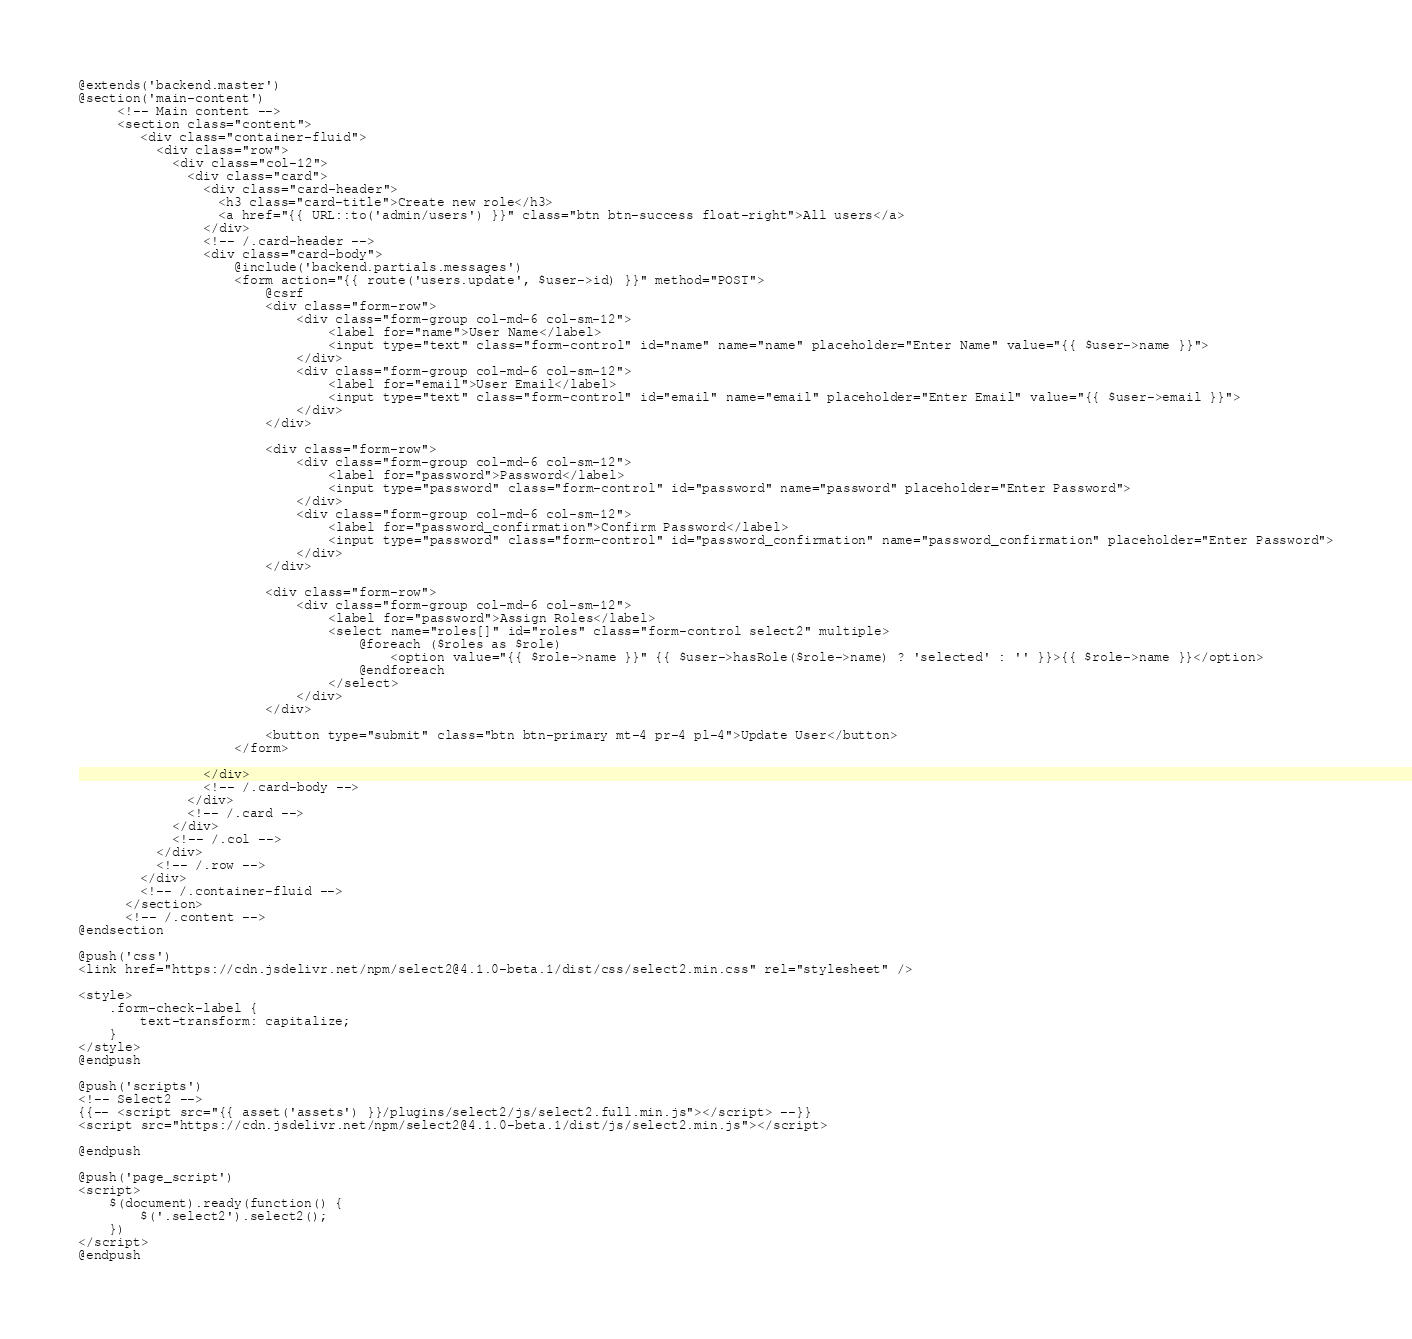<code> <loc_0><loc_0><loc_500><loc_500><_PHP_>@extends('backend.master')
@section('main-content')
     <!-- Main content -->
     <section class="content">
        <div class="container-fluid">
          <div class="row">
            <div class="col-12">
              <div class="card">
                <div class="card-header">
                  <h3 class="card-title">Create new role</h3>
                  <a href="{{ URL::to('admin/users') }}" class="btn btn-success float-right">All users</a>
                </div>
                <!-- /.card-header -->
                <div class="card-body">
                    @include('backend.partials.messages')
                    <form action="{{ route('users.update', $user->id) }}" method="POST">
                        @csrf
                        <div class="form-row">
                            <div class="form-group col-md-6 col-sm-12">
                                <label for="name">User Name</label>
                                <input type="text" class="form-control" id="name" name="name" placeholder="Enter Name" value="{{ $user->name }}">
                            </div>
                            <div class="form-group col-md-6 col-sm-12">
                                <label for="email">User Email</label>
                                <input type="text" class="form-control" id="email" name="email" placeholder="Enter Email" value="{{ $user->email }}">
                            </div>
                        </div>

                        <div class="form-row">
                            <div class="form-group col-md-6 col-sm-12">
                                <label for="password">Password</label>
                                <input type="password" class="form-control" id="password" name="password" placeholder="Enter Password">
                            </div>
                            <div class="form-group col-md-6 col-sm-12">
                                <label for="password_confirmation">Confirm Password</label>
                                <input type="password" class="form-control" id="password_confirmation" name="password_confirmation" placeholder="Enter Password">
                            </div>
                        </div>

                        <div class="form-row">
                            <div class="form-group col-md-6 col-sm-12">
                                <label for="password">Assign Roles</label>
                                <select name="roles[]" id="roles" class="form-control select2" multiple>
                                    @foreach ($roles as $role)
                                        <option value="{{ $role->name }}" {{ $user->hasRole($role->name) ? 'selected' : '' }}>{{ $role->name }}</option>
                                    @endforeach
                                </select>
                            </div>
                        </div>
                        
                        <button type="submit" class="btn btn-primary mt-4 pr-4 pl-4">Update User</button>
                    </form>

                </div>
                <!-- /.card-body -->
              </div>
              <!-- /.card -->
            </div>
            <!-- /.col -->
          </div>
          <!-- /.row -->
        </div>
        <!-- /.container-fluid -->
      </section>
      <!-- /.content -->
@endsection

@push('css')
<link href="https://cdn.jsdelivr.net/npm/select2@4.1.0-beta.1/dist/css/select2.min.css" rel="stylesheet" />

<style>
    .form-check-label {
        text-transform: capitalize;
    }
</style>
@endpush

@push('scripts')
<!-- Select2 -->
{{-- <script src="{{ asset('assets') }}/plugins/select2/js/select2.full.min.js"></script> --}}
<script src="https://cdn.jsdelivr.net/npm/select2@4.1.0-beta.1/dist/js/select2.min.js"></script>

@endpush

@push('page_script')
<script>
    $(document).ready(function() {
        $('.select2').select2();
    })
</script>
@endpush</code> 